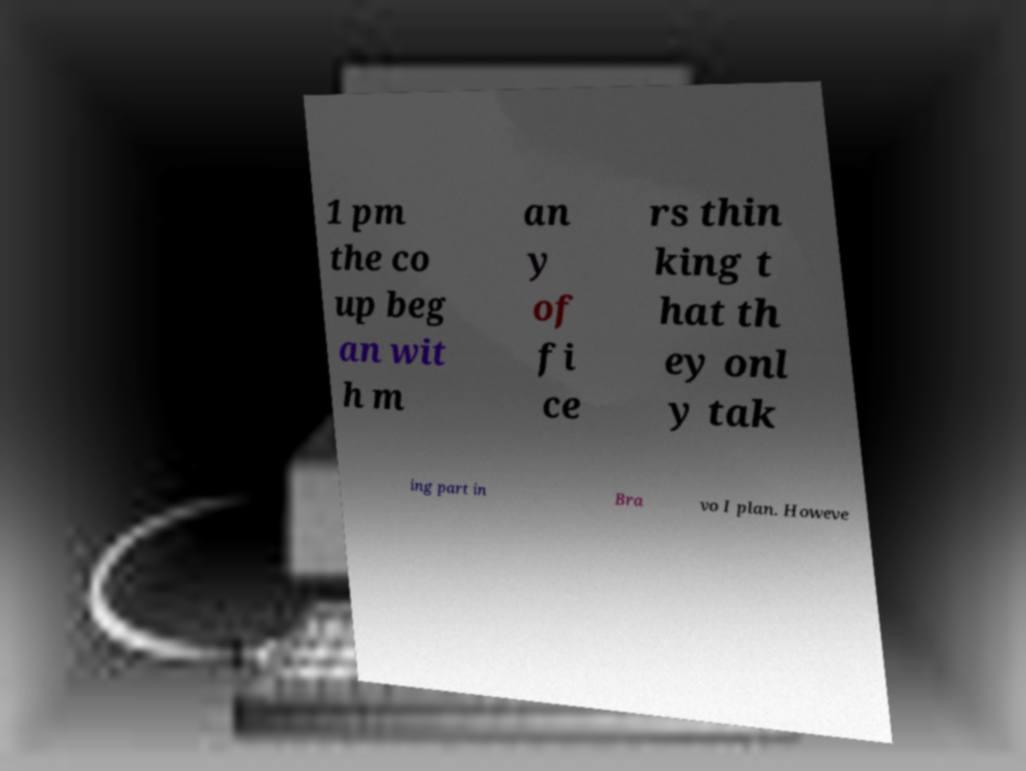Can you accurately transcribe the text from the provided image for me? 1 pm the co up beg an wit h m an y of fi ce rs thin king t hat th ey onl y tak ing part in Bra vo I plan. Howeve 